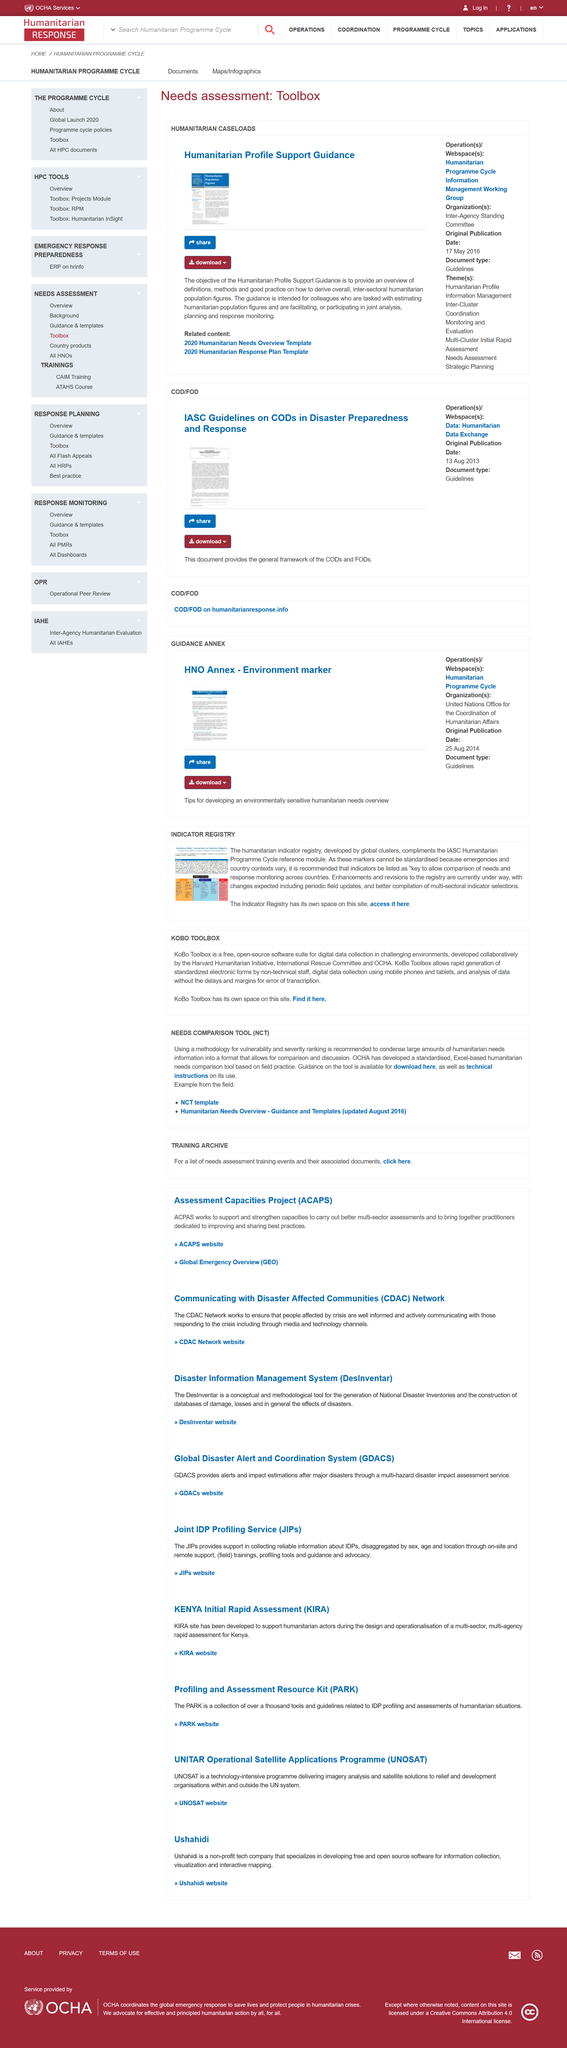Mention a couple of crucial points in this snapshot. The Kenya Initial Rapid Assessment has been created to aid humanitarian actors in the design and implementation of a comprehensive, multi-agency rapid assessment for Kenya, aimed at addressing the needs of those affected by the crisis. There is a humanitarian indicator registry that exists. UNOSAT is an acronym for UNITAR Operational Satellite Applications Programme, which is a technology-intensive programme aimed at utilizing satellite imagery for various applications, including disaster management, environmental monitoring, and humanitarian assistance. ACAPS stands for the Assessment Capacities Project, which focuses on improving the assessment capacities of various organizations and individuals. The last update of the Humanitarian Needs Overview was in August 2016. 